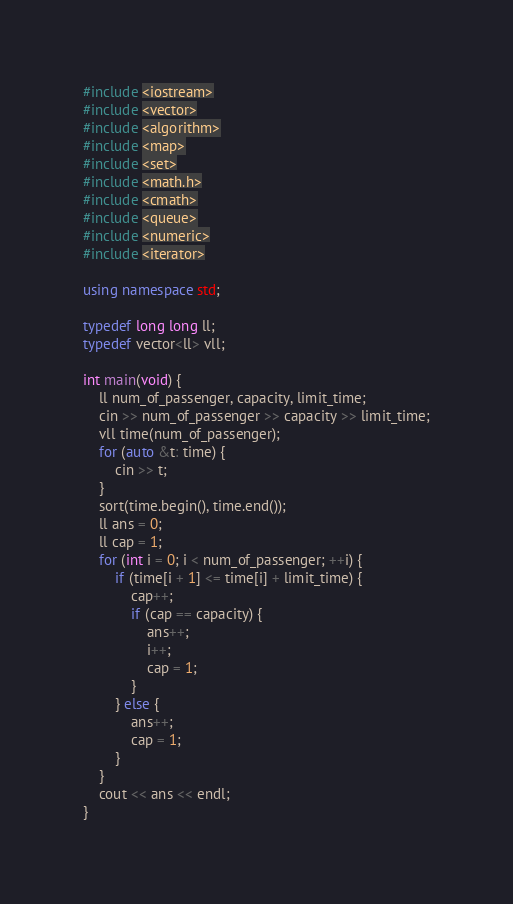<code> <loc_0><loc_0><loc_500><loc_500><_C++_>#include <iostream>
#include <vector>
#include <algorithm>
#include <map>
#include <set>
#include <math.h>
#include <cmath>
#include <queue>
#include <numeric>
#include <iterator>

using namespace std;

typedef long long ll;
typedef vector<ll> vll;

int main(void) {
    ll num_of_passenger, capacity, limit_time;
    cin >> num_of_passenger >> capacity >> limit_time;
    vll time(num_of_passenger);
    for (auto &t: time) {
        cin >> t;
    }
    sort(time.begin(), time.end());
    ll ans = 0;
    ll cap = 1;
    for (int i = 0; i < num_of_passenger; ++i) {
        if (time[i + 1] <= time[i] + limit_time) {
            cap++;
            if (cap == capacity) {
                ans++;
                i++;
                cap = 1;
            }
        } else {
            ans++;
            cap = 1;
        }
    }
    cout << ans << endl;
}</code> 